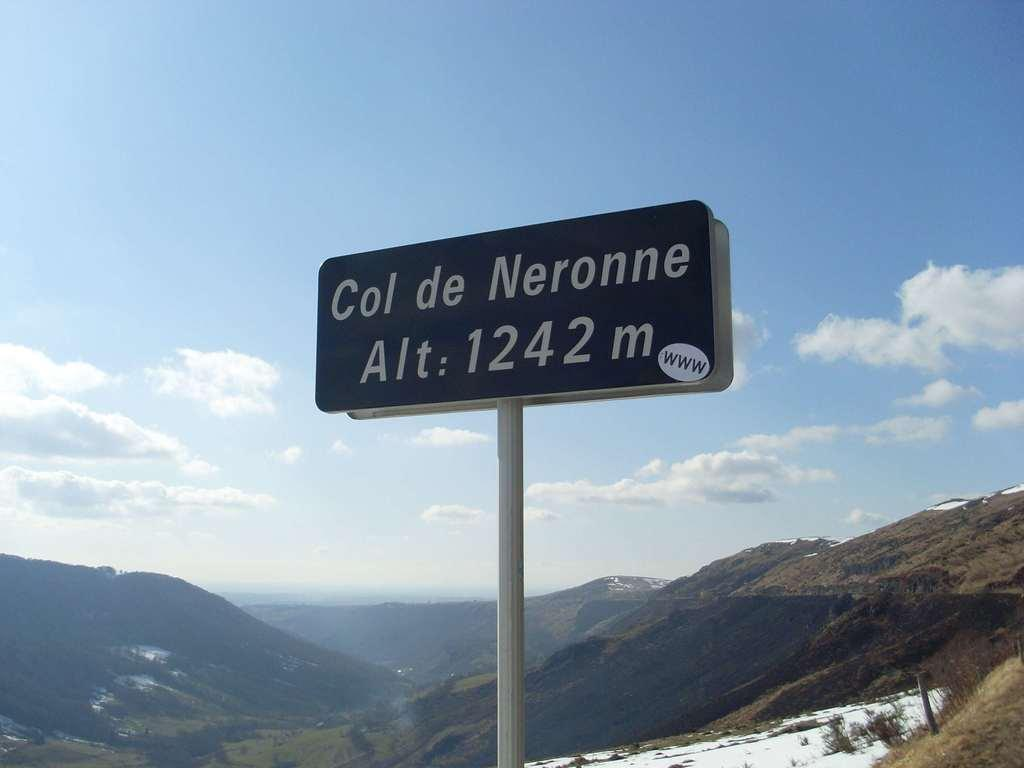<image>
Describe the image concisely. Blue sign which says "col de Neronne" in front of some mountains. 